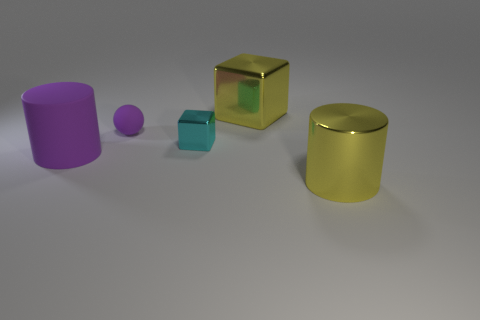Add 5 cubes. How many objects exist? 10 Subtract all cylinders. How many objects are left? 3 Subtract all brown metal things. Subtract all large blocks. How many objects are left? 4 Add 2 tiny spheres. How many tiny spheres are left? 3 Add 1 big yellow cylinders. How many big yellow cylinders exist? 2 Subtract 0 gray balls. How many objects are left? 5 